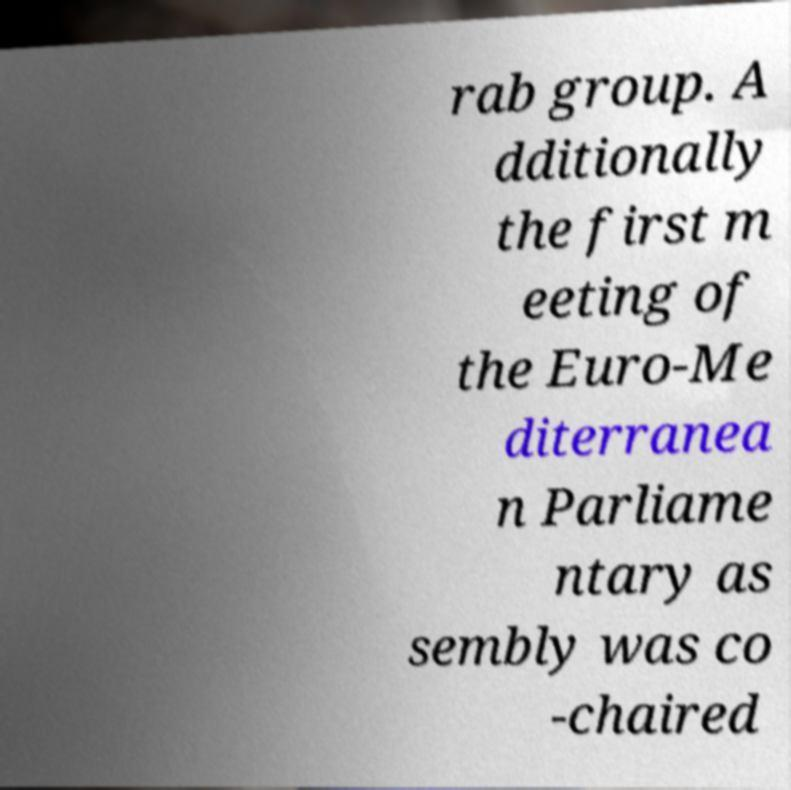I need the written content from this picture converted into text. Can you do that? rab group. A dditionally the first m eeting of the Euro-Me diterranea n Parliame ntary as sembly was co -chaired 